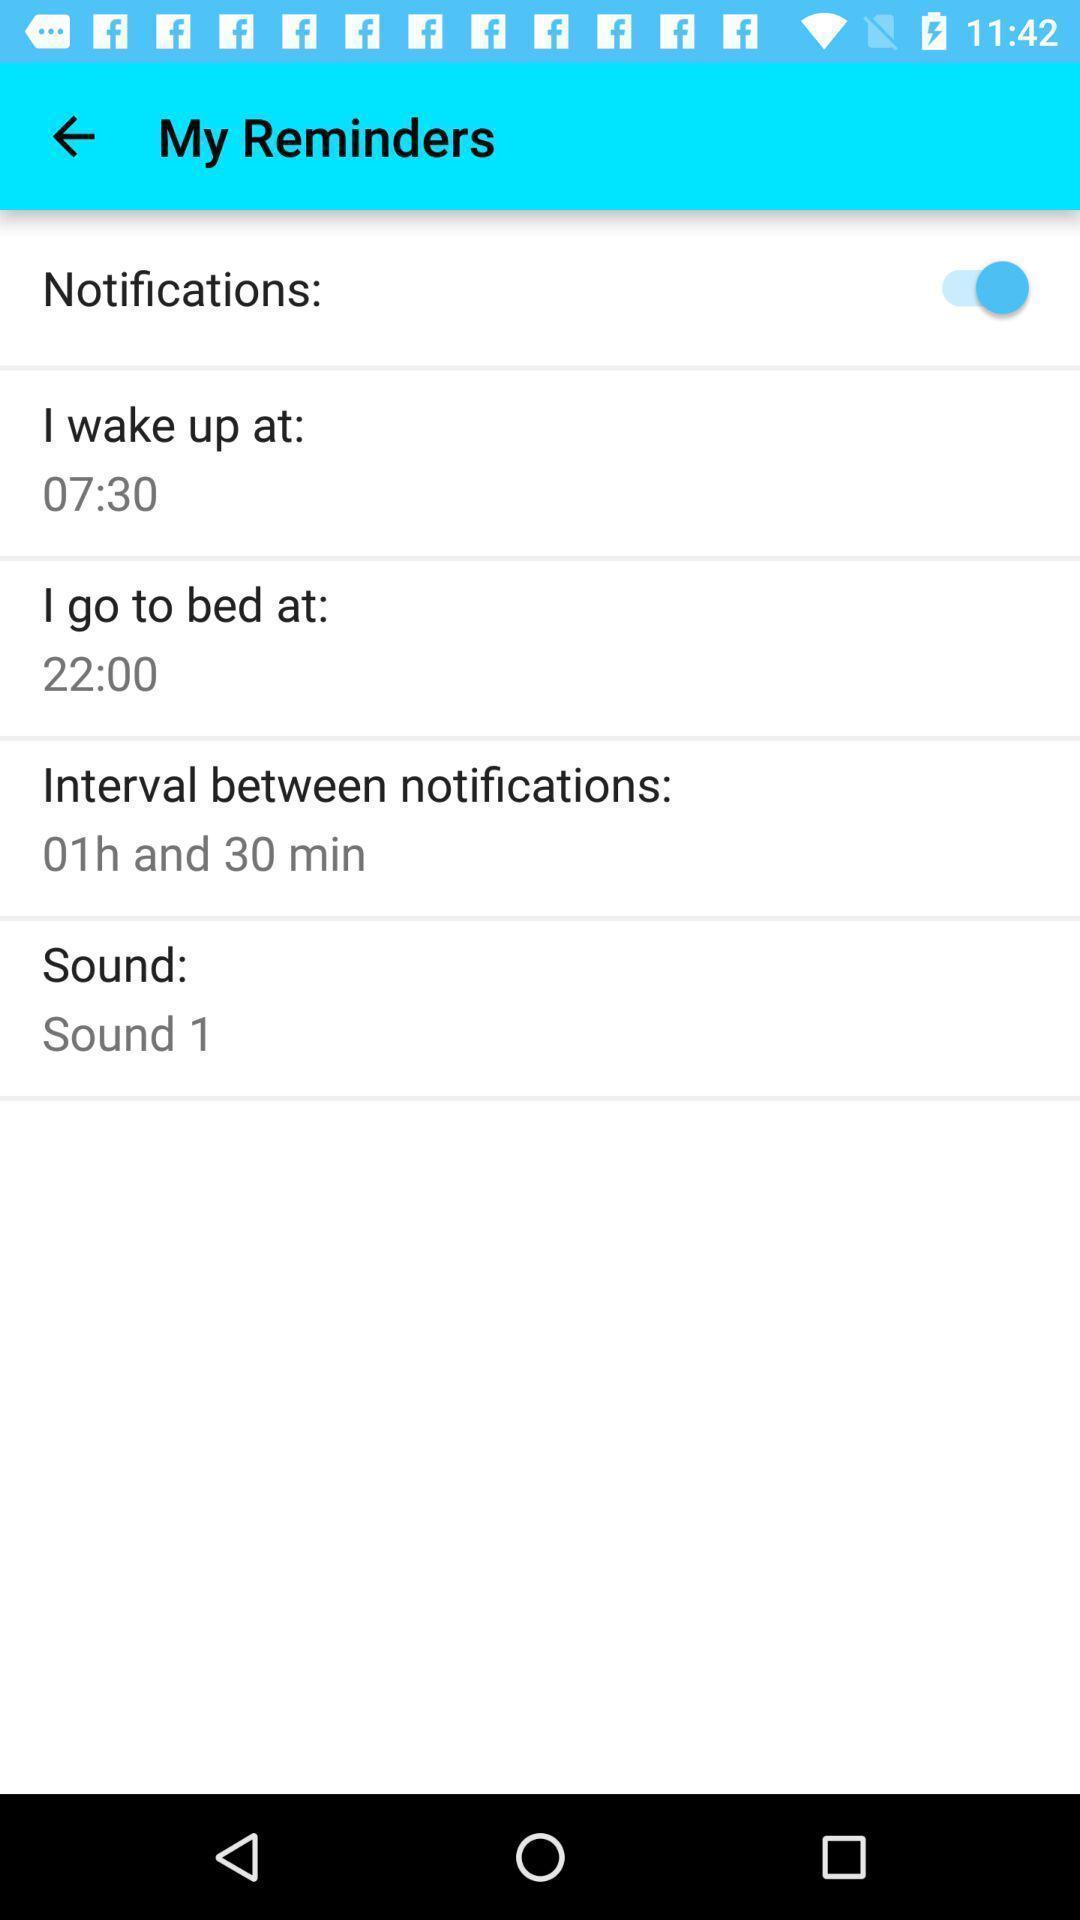Please provide a description for this image. Screen displaying my reminders page with set up options. 